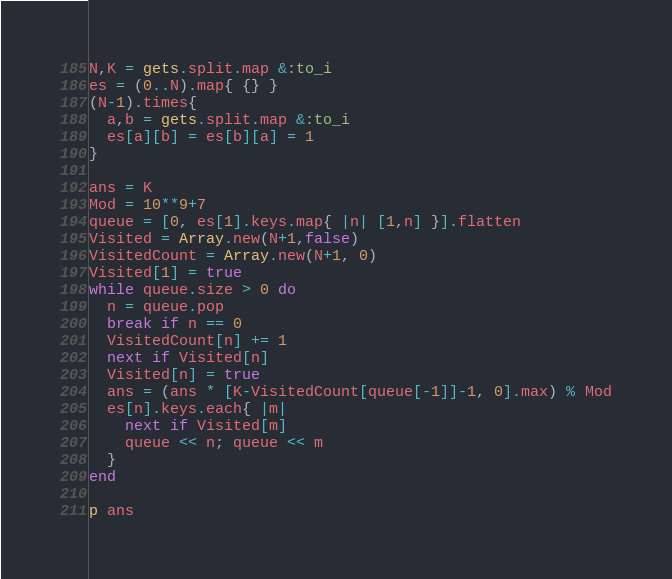<code> <loc_0><loc_0><loc_500><loc_500><_Ruby_>N,K = gets.split.map &:to_i
es = (0..N).map{ {} }
(N-1).times{
  a,b = gets.split.map &:to_i
  es[a][b] = es[b][a] = 1
}

ans = K
Mod = 10**9+7
queue = [0, es[1].keys.map{ |n| [1,n] }].flatten
Visited = Array.new(N+1,false)
VisitedCount = Array.new(N+1, 0)
Visited[1] = true
while queue.size > 0 do
  n = queue.pop
  break if n == 0
  VisitedCount[n] += 1
  next if Visited[n]
  Visited[n] = true
  ans = (ans * [K-VisitedCount[queue[-1]]-1, 0].max) % Mod
  es[n].keys.each{ |m|
    next if Visited[m]
    queue << n; queue << m
  }
end

p ans</code> 